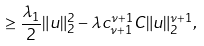Convert formula to latex. <formula><loc_0><loc_0><loc_500><loc_500>\geq \frac { \lambda _ { 1 } } { 2 } \| u \| _ { 2 } ^ { 2 } - \lambda c _ { \nu + 1 } ^ { \nu + 1 } C \| u \| _ { 2 } ^ { \nu + 1 } ,</formula> 